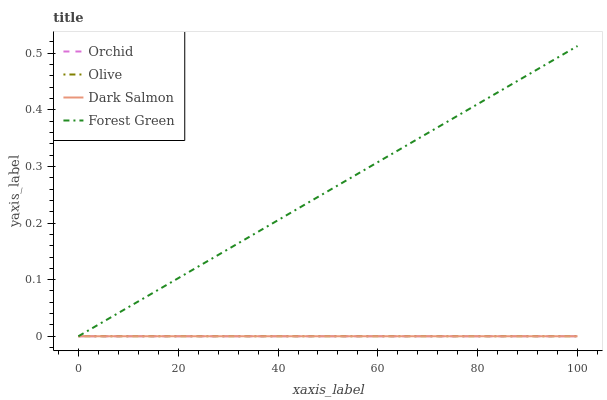Does Forest Green have the minimum area under the curve?
Answer yes or no. No. Does Dark Salmon have the maximum area under the curve?
Answer yes or no. No. Is Forest Green the smoothest?
Answer yes or no. No. Is Dark Salmon the roughest?
Answer yes or no. No. Does Dark Salmon have the highest value?
Answer yes or no. No. 